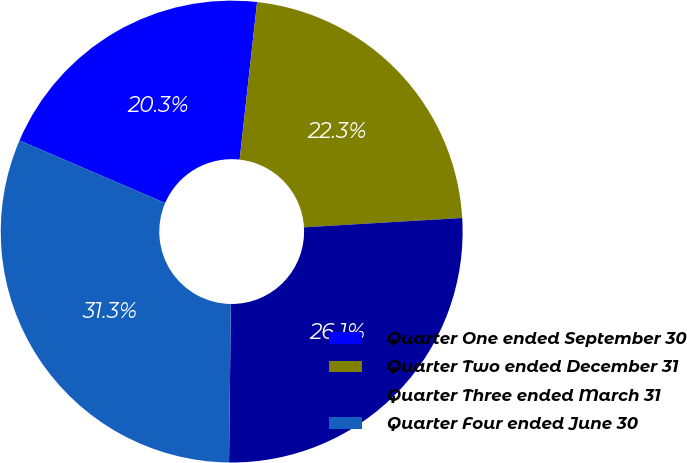<chart> <loc_0><loc_0><loc_500><loc_500><pie_chart><fcel>Quarter One ended September 30<fcel>Quarter Two ended December 31<fcel>Quarter Three ended March 31<fcel>Quarter Four ended June 30<nl><fcel>20.3%<fcel>22.31%<fcel>26.12%<fcel>31.28%<nl></chart> 